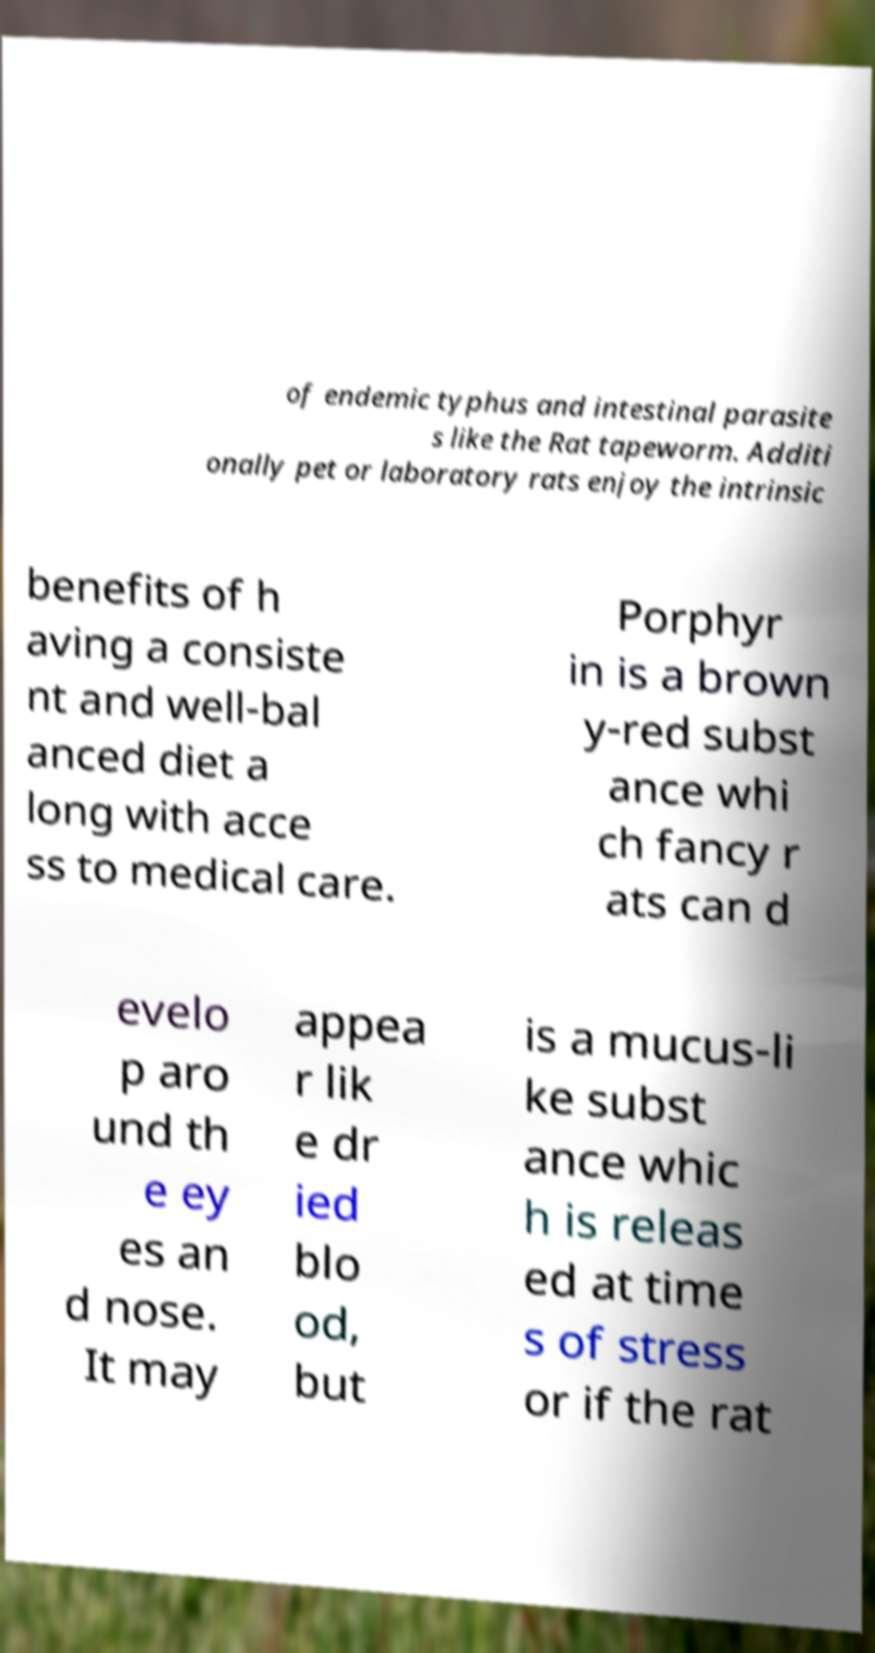I need the written content from this picture converted into text. Can you do that? of endemic typhus and intestinal parasite s like the Rat tapeworm. Additi onally pet or laboratory rats enjoy the intrinsic benefits of h aving a consiste nt and well-bal anced diet a long with acce ss to medical care. Porphyr in is a brown y-red subst ance whi ch fancy r ats can d evelo p aro und th e ey es an d nose. It may appea r lik e dr ied blo od, but is a mucus-li ke subst ance whic h is releas ed at time s of stress or if the rat 